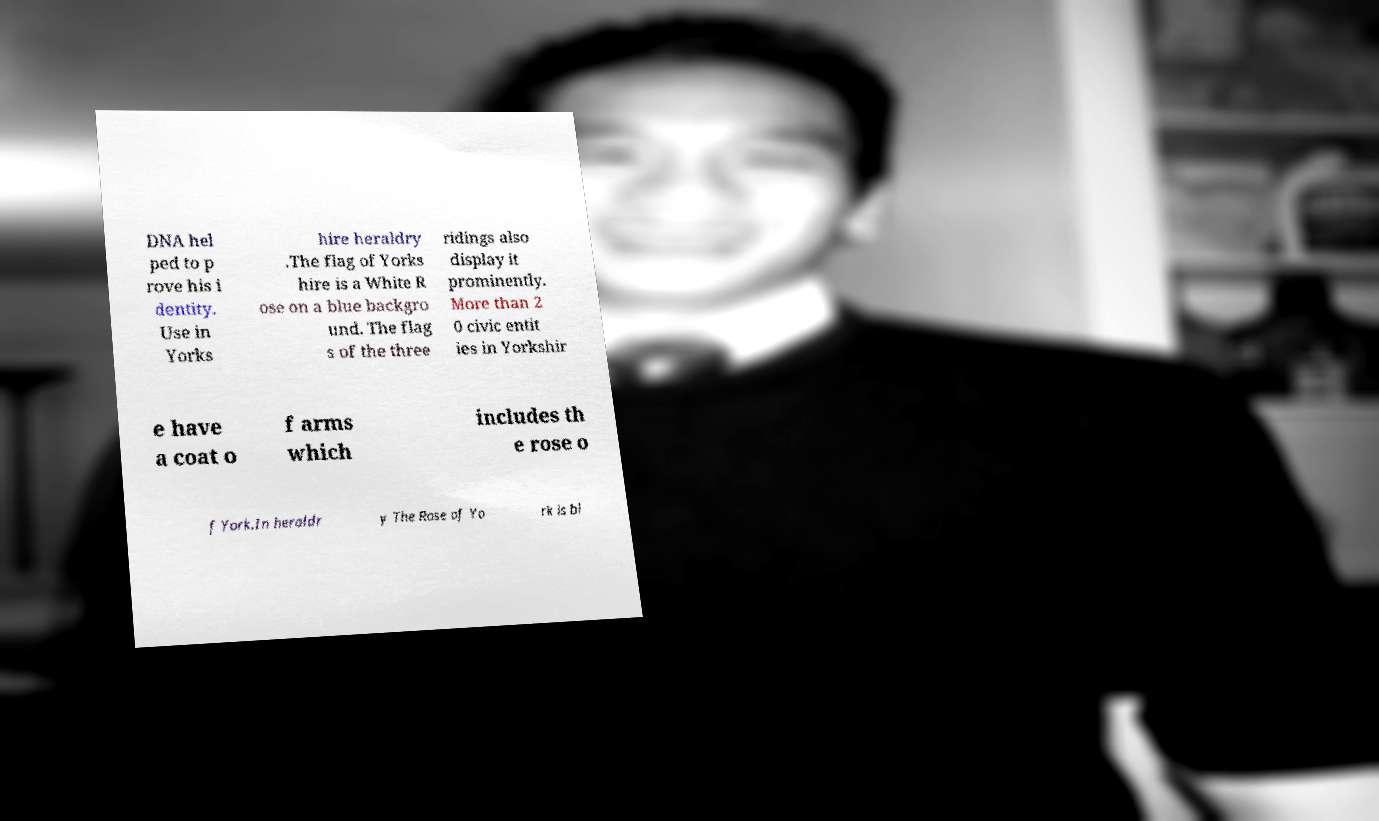Can you accurately transcribe the text from the provided image for me? DNA hel ped to p rove his i dentity. Use in Yorks hire heraldry .The flag of Yorks hire is a White R ose on a blue backgro und. The flag s of the three ridings also display it prominently. More than 2 0 civic entit ies in Yorkshir e have a coat o f arms which includes th e rose o f York.In heraldr y The Rose of Yo rk is bl 